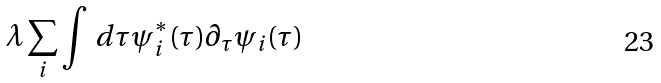<formula> <loc_0><loc_0><loc_500><loc_500>\lambda \sum _ { i } \int \, d \tau \psi ^ { * } _ { i } ( \tau ) \partial _ { \tau } \psi _ { i } ( \tau )</formula> 